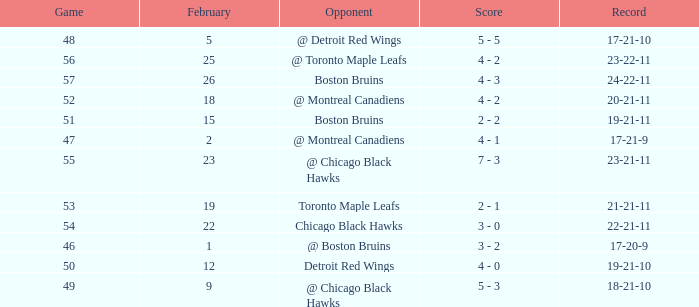What is the score of the game before 56 held after February 18 against the Chicago Black Hawks. 3 - 0. 